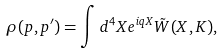<formula> <loc_0><loc_0><loc_500><loc_500>\rho ( p , p ^ { \prime } ) = \int d ^ { 4 } X e ^ { i q X } \tilde { W } ( X , K ) ,</formula> 